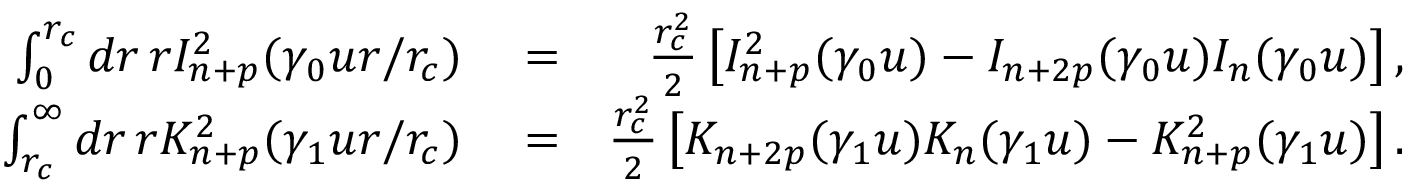<formula> <loc_0><loc_0><loc_500><loc_500>\begin{array} { r l r } { \int _ { 0 } ^ { r _ { c } } d r \, r I _ { n + p } ^ { 2 } ( \gamma _ { 0 } u r / r _ { c } ) } & = } & { \frac { r _ { c } ^ { 2 } } { 2 } \left [ I _ { n + p } ^ { 2 } ( \gamma _ { 0 } u ) - I _ { n + 2 p } ( \gamma _ { 0 } u ) I _ { n } ( \gamma _ { 0 } u ) \right ] , } \\ { \int _ { r _ { c } } ^ { \infty } d r \, r K _ { n + p } ^ { 2 } ( \gamma _ { 1 } u r / r _ { c } ) } & = } & { \frac { r _ { c } ^ { 2 } } { 2 } \left [ K _ { n + 2 p } ( \gamma _ { 1 } u ) K _ { n } ( \gamma _ { 1 } u ) - K _ { n + p } ^ { 2 } ( \gamma _ { 1 } u ) \right ] . } \end{array}</formula> 